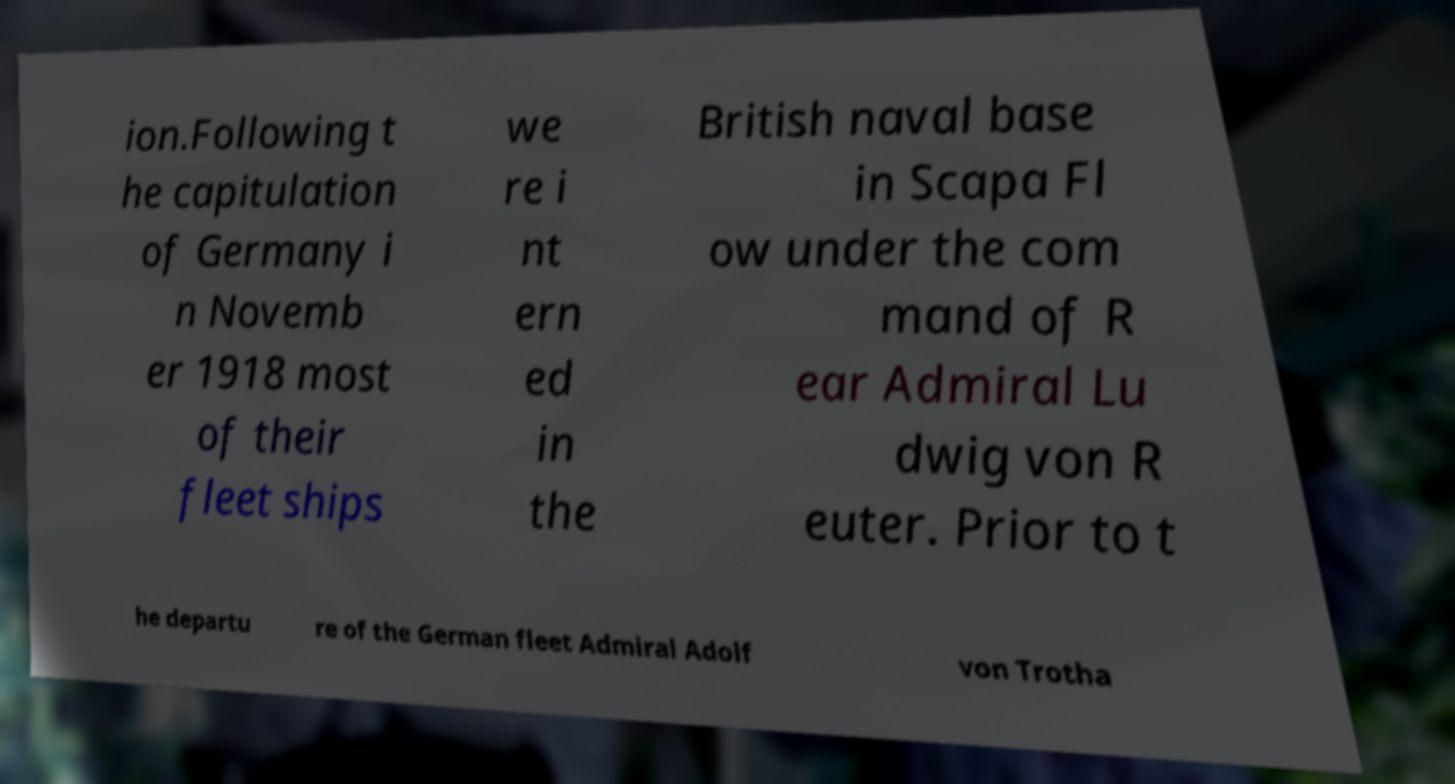Can you read and provide the text displayed in the image?This photo seems to have some interesting text. Can you extract and type it out for me? ion.Following t he capitulation of Germany i n Novemb er 1918 most of their fleet ships we re i nt ern ed in the British naval base in Scapa Fl ow under the com mand of R ear Admiral Lu dwig von R euter. Prior to t he departu re of the German fleet Admiral Adolf von Trotha 